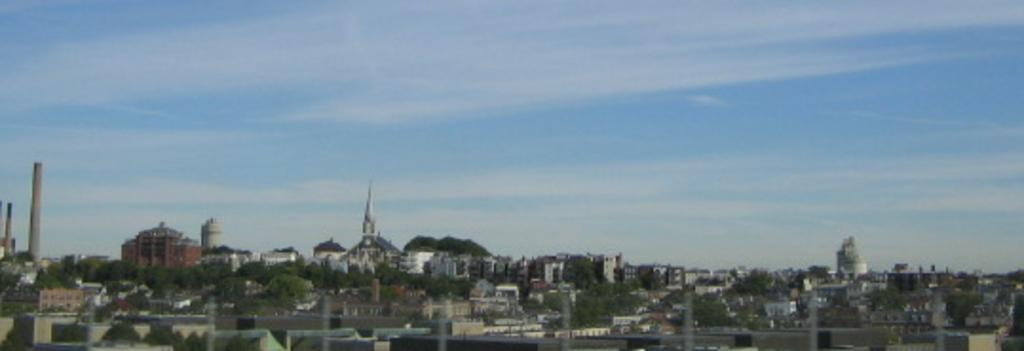What type of structures are present in the image? There are buildings in the image. What other natural elements can be seen in the image? There are trees in the image. Where are the buildings and trees located in the image? The buildings and trees are at the bottom side of the image. What is visible at the top side of the image? The sky is visible at the top side of the image. How far is the spark from the buildings in the image? There is no spark present in the image, so it cannot be determined how far it might be from the buildings. 